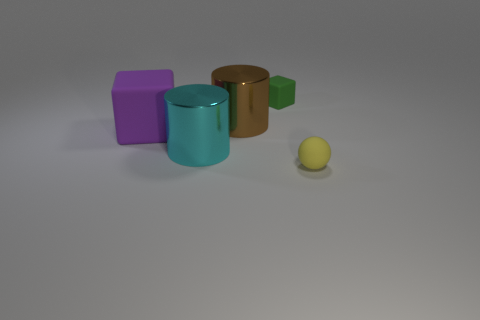Is there any other thing that is the same shape as the tiny yellow object?
Keep it short and to the point. No. How many spheres are tiny yellow objects or big brown metallic things?
Give a very brief answer. 1. There is a tiny thing that is made of the same material as the yellow ball; what is its color?
Your answer should be very brief. Green. There is a matte cube that is in front of the green object; is it the same size as the sphere?
Provide a succinct answer. No. Is the material of the big brown thing the same as the big cyan cylinder in front of the purple matte cube?
Ensure brevity in your answer.  Yes. The matte object that is behind the large matte cube is what color?
Offer a very short reply. Green. There is a small thing that is to the left of the yellow object; are there any cubes left of it?
Your answer should be compact. Yes. There is a small cube; how many big metal objects are on the right side of it?
Your response must be concise. 0. What number of tiny rubber things are the same color as the small ball?
Ensure brevity in your answer.  0. Are the block right of the large matte object and the yellow sphere made of the same material?
Your response must be concise. Yes. 